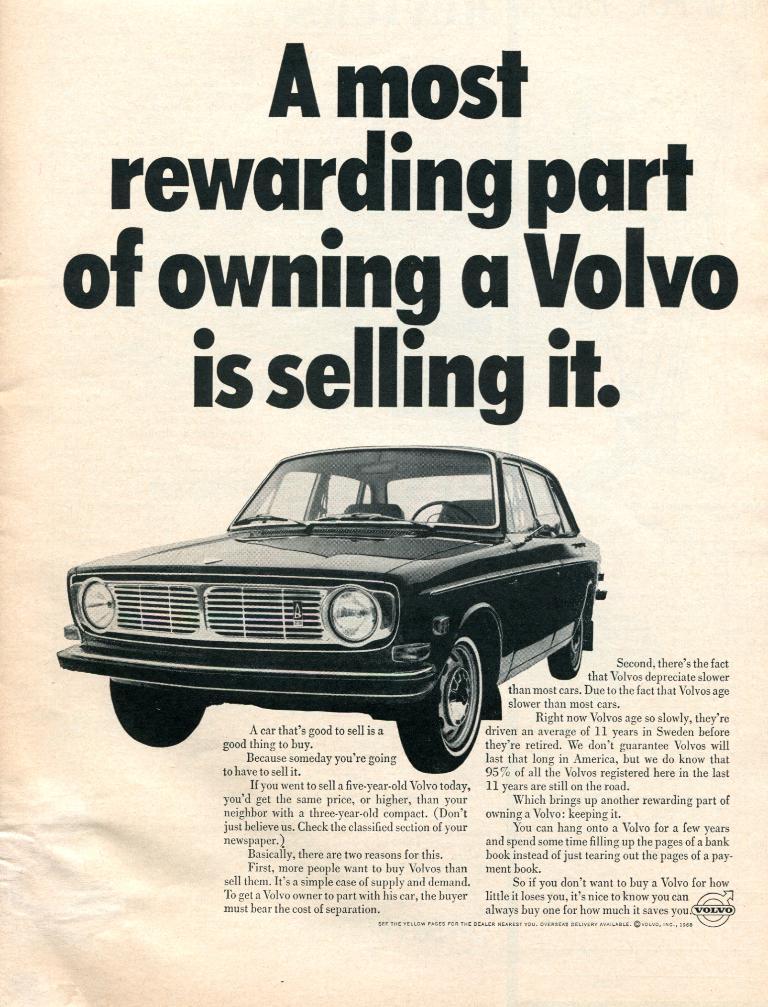How would you summarize this image in a sentence or two? In this image we can see a poster with some text and an image. 